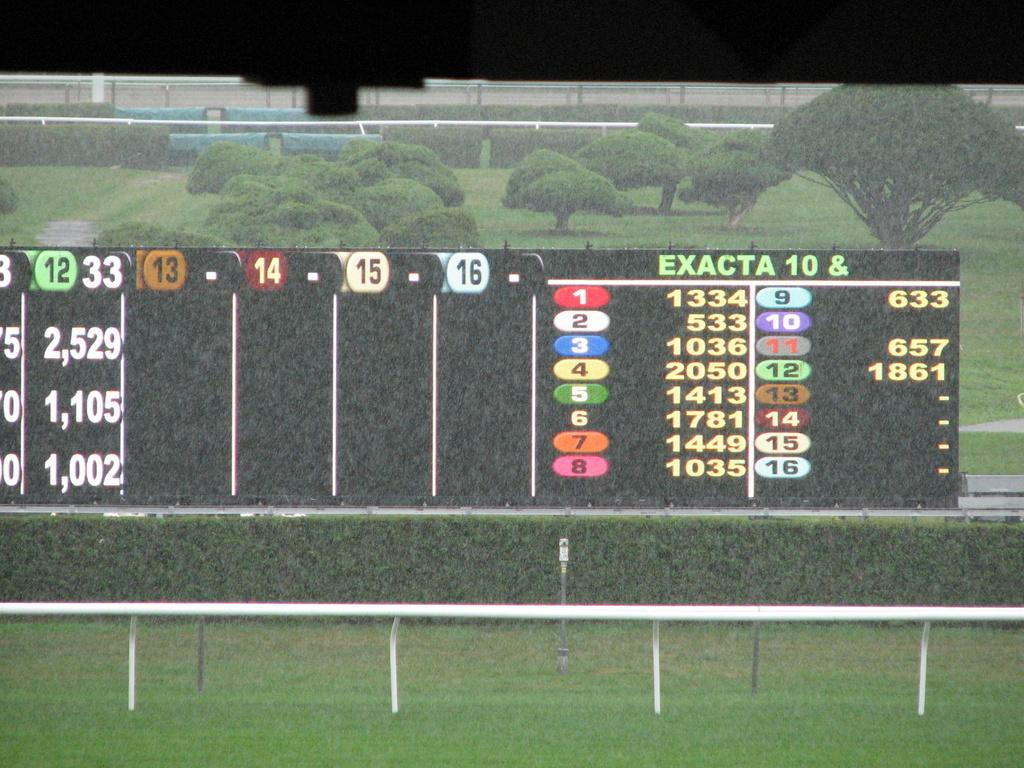<image>
Relay a brief, clear account of the picture shown. On the board number 1 is 1334 and number 8 is 1035. 